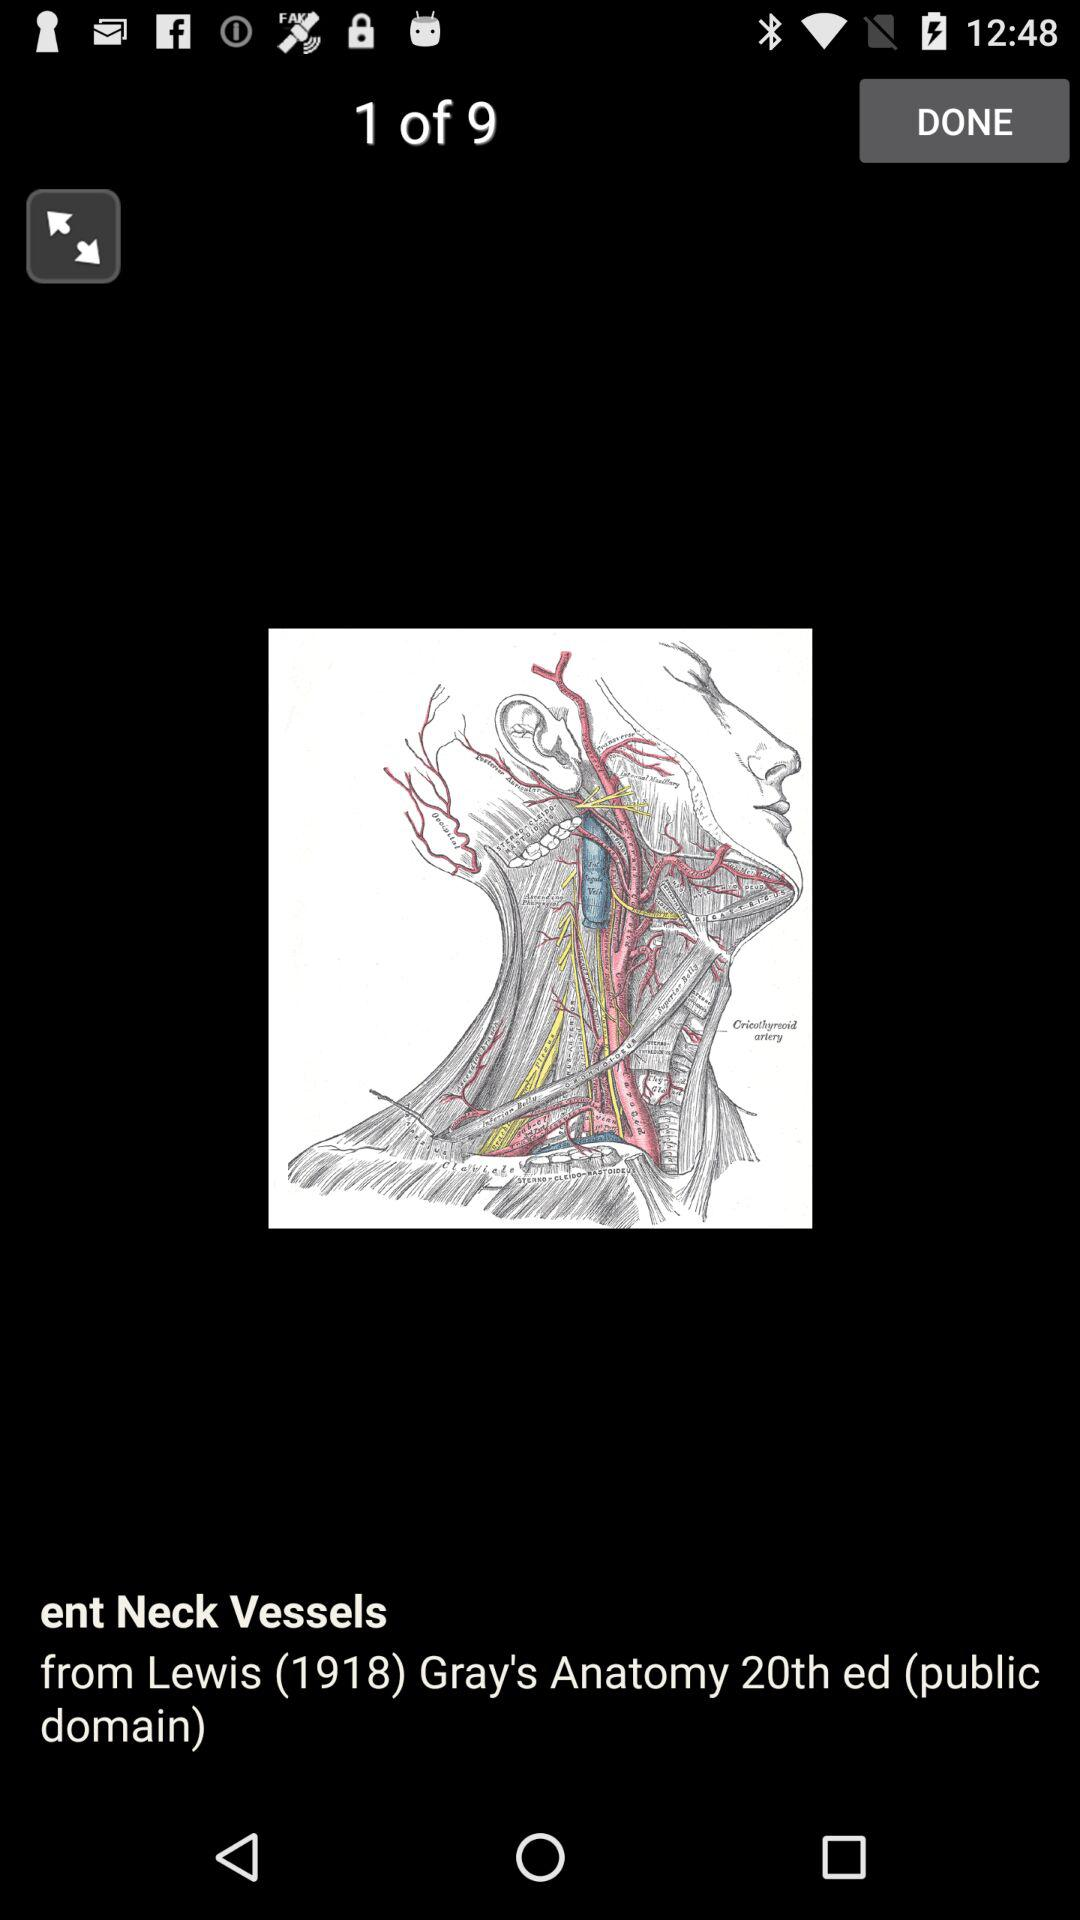What's the total count? The total count is 9. 